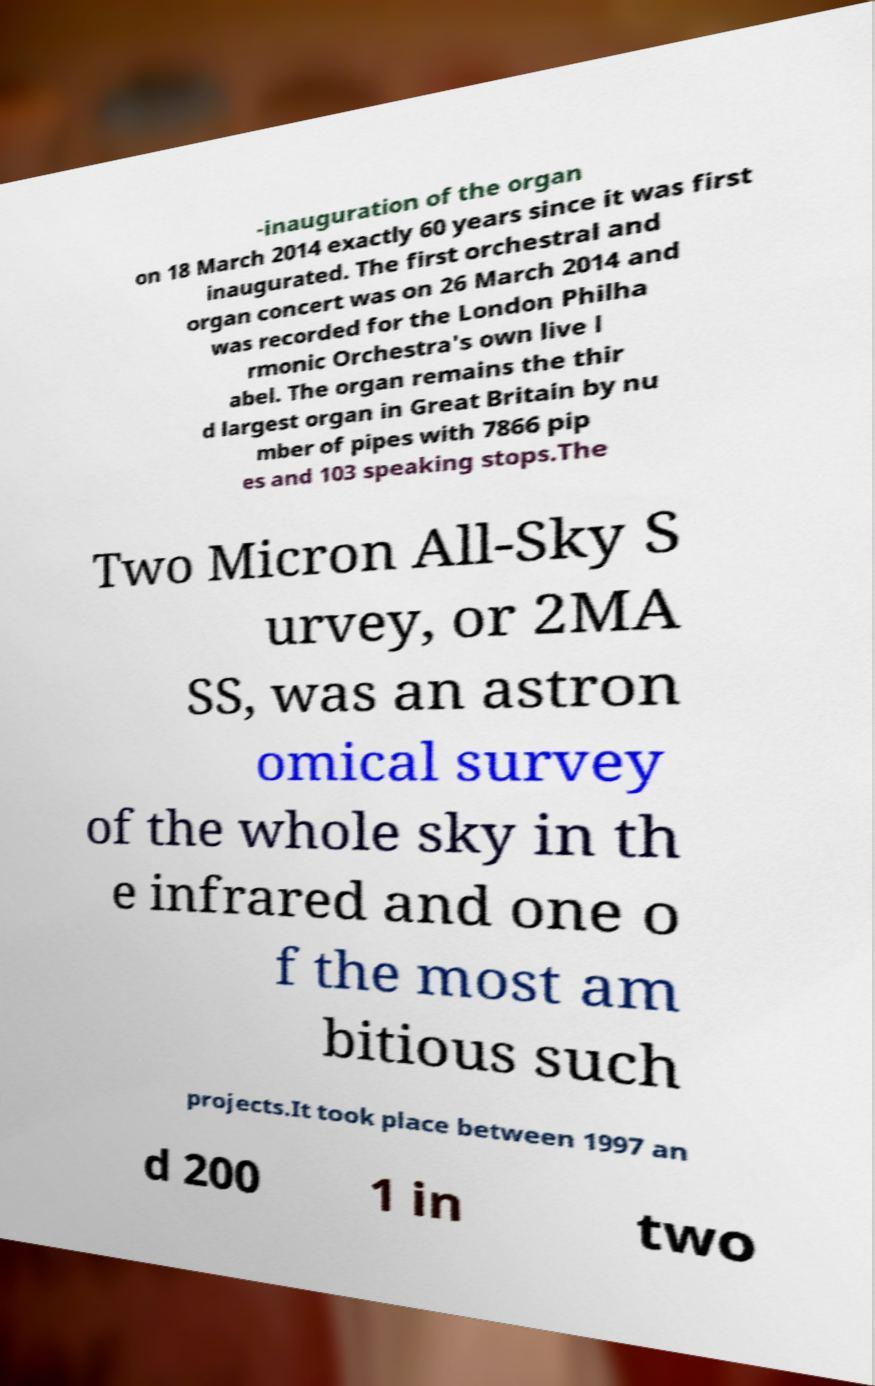Could you assist in decoding the text presented in this image and type it out clearly? -inauguration of the organ on 18 March 2014 exactly 60 years since it was first inaugurated. The first orchestral and organ concert was on 26 March 2014 and was recorded for the London Philha rmonic Orchestra's own live l abel. The organ remains the thir d largest organ in Great Britain by nu mber of pipes with 7866 pip es and 103 speaking stops.The Two Micron All-Sky S urvey, or 2MA SS, was an astron omical survey of the whole sky in th e infrared and one o f the most am bitious such projects.It took place between 1997 an d 200 1 in two 